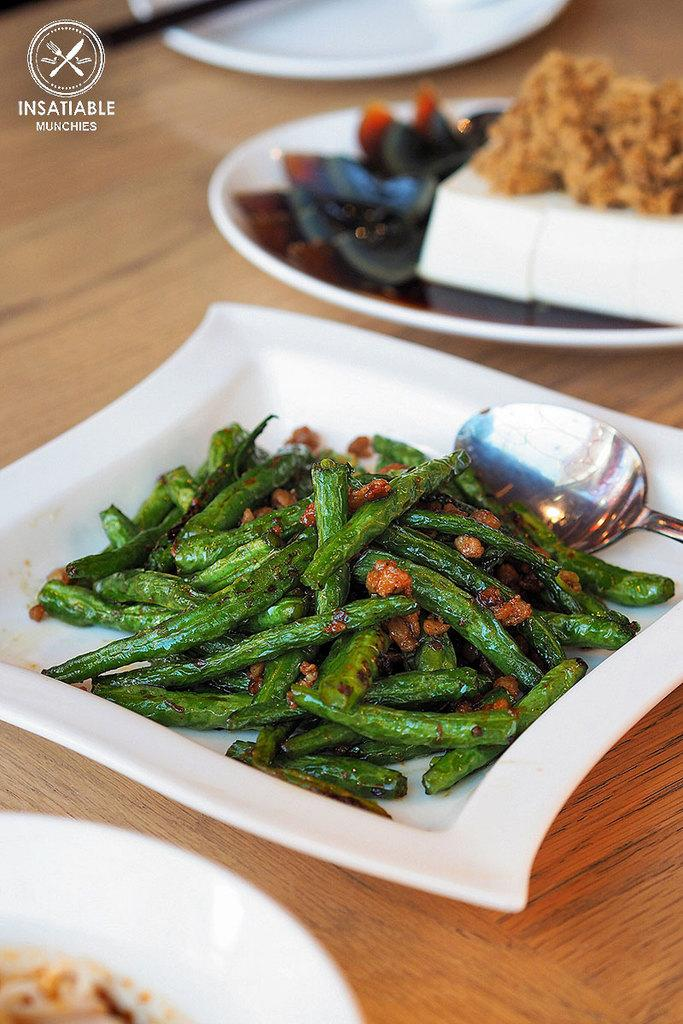What is on the plates in the image? There are food items on plates in the image. Can you describe any utensils present with the food? Yes, there is a spoon on one of the plates. What type of surface are the plates resting on? The plates are on a wooden surface. What else can be seen in the image besides the food and plates? There is text visible in the image. How many sisters are holding the plates in the image? There are no people holding the plates in the image; the plates are resting on a wooden surface. What type of cap is being worn by the food in the image? There is no cap present in the image, as the subject is food on plates. 